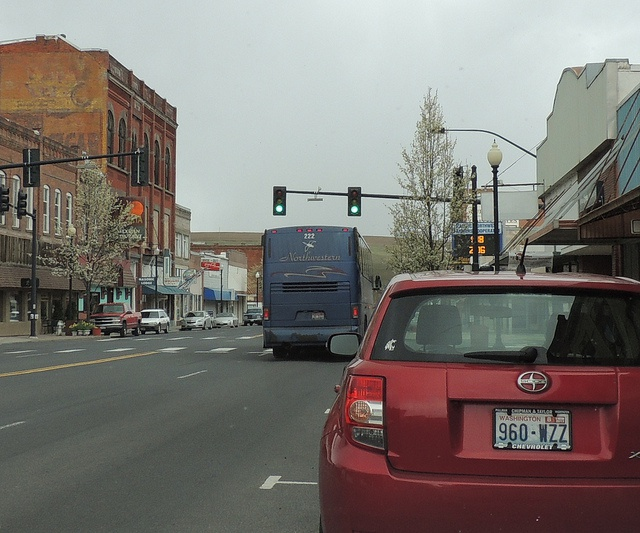Describe the objects in this image and their specific colors. I can see car in lightgray, maroon, black, gray, and brown tones, bus in lightgray, gray, black, and darkblue tones, truck in lightgray, black, gray, darkgray, and maroon tones, traffic light in lightgray, black, gray, and darkgray tones, and car in lightgray, black, gray, and darkgray tones in this image. 